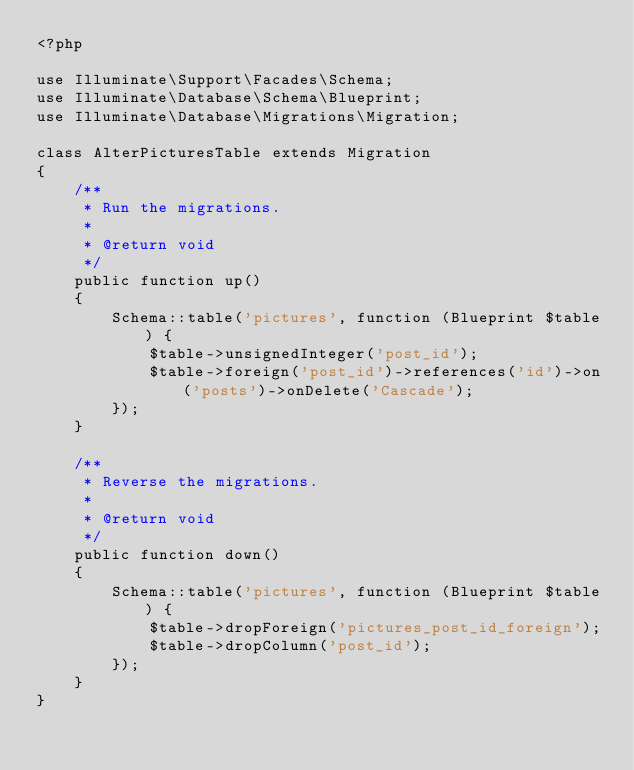Convert code to text. <code><loc_0><loc_0><loc_500><loc_500><_PHP_><?php

use Illuminate\Support\Facades\Schema;
use Illuminate\Database\Schema\Blueprint;
use Illuminate\Database\Migrations\Migration;

class AlterPicturesTable extends Migration
{
    /**
     * Run the migrations.
     *
     * @return void
     */
    public function up()
    {
        Schema::table('pictures', function (Blueprint $table) {
            $table->unsignedInteger('post_id');
            $table->foreign('post_id')->references('id')->on('posts')->onDelete('Cascade');
        });
    }

    /**
     * Reverse the migrations.
     *
     * @return void
     */
    public function down()
    {
        Schema::table('pictures', function (Blueprint $table) {
            $table->dropForeign('pictures_post_id_foreign');
            $table->dropColumn('post_id');
        });
    }
}
</code> 